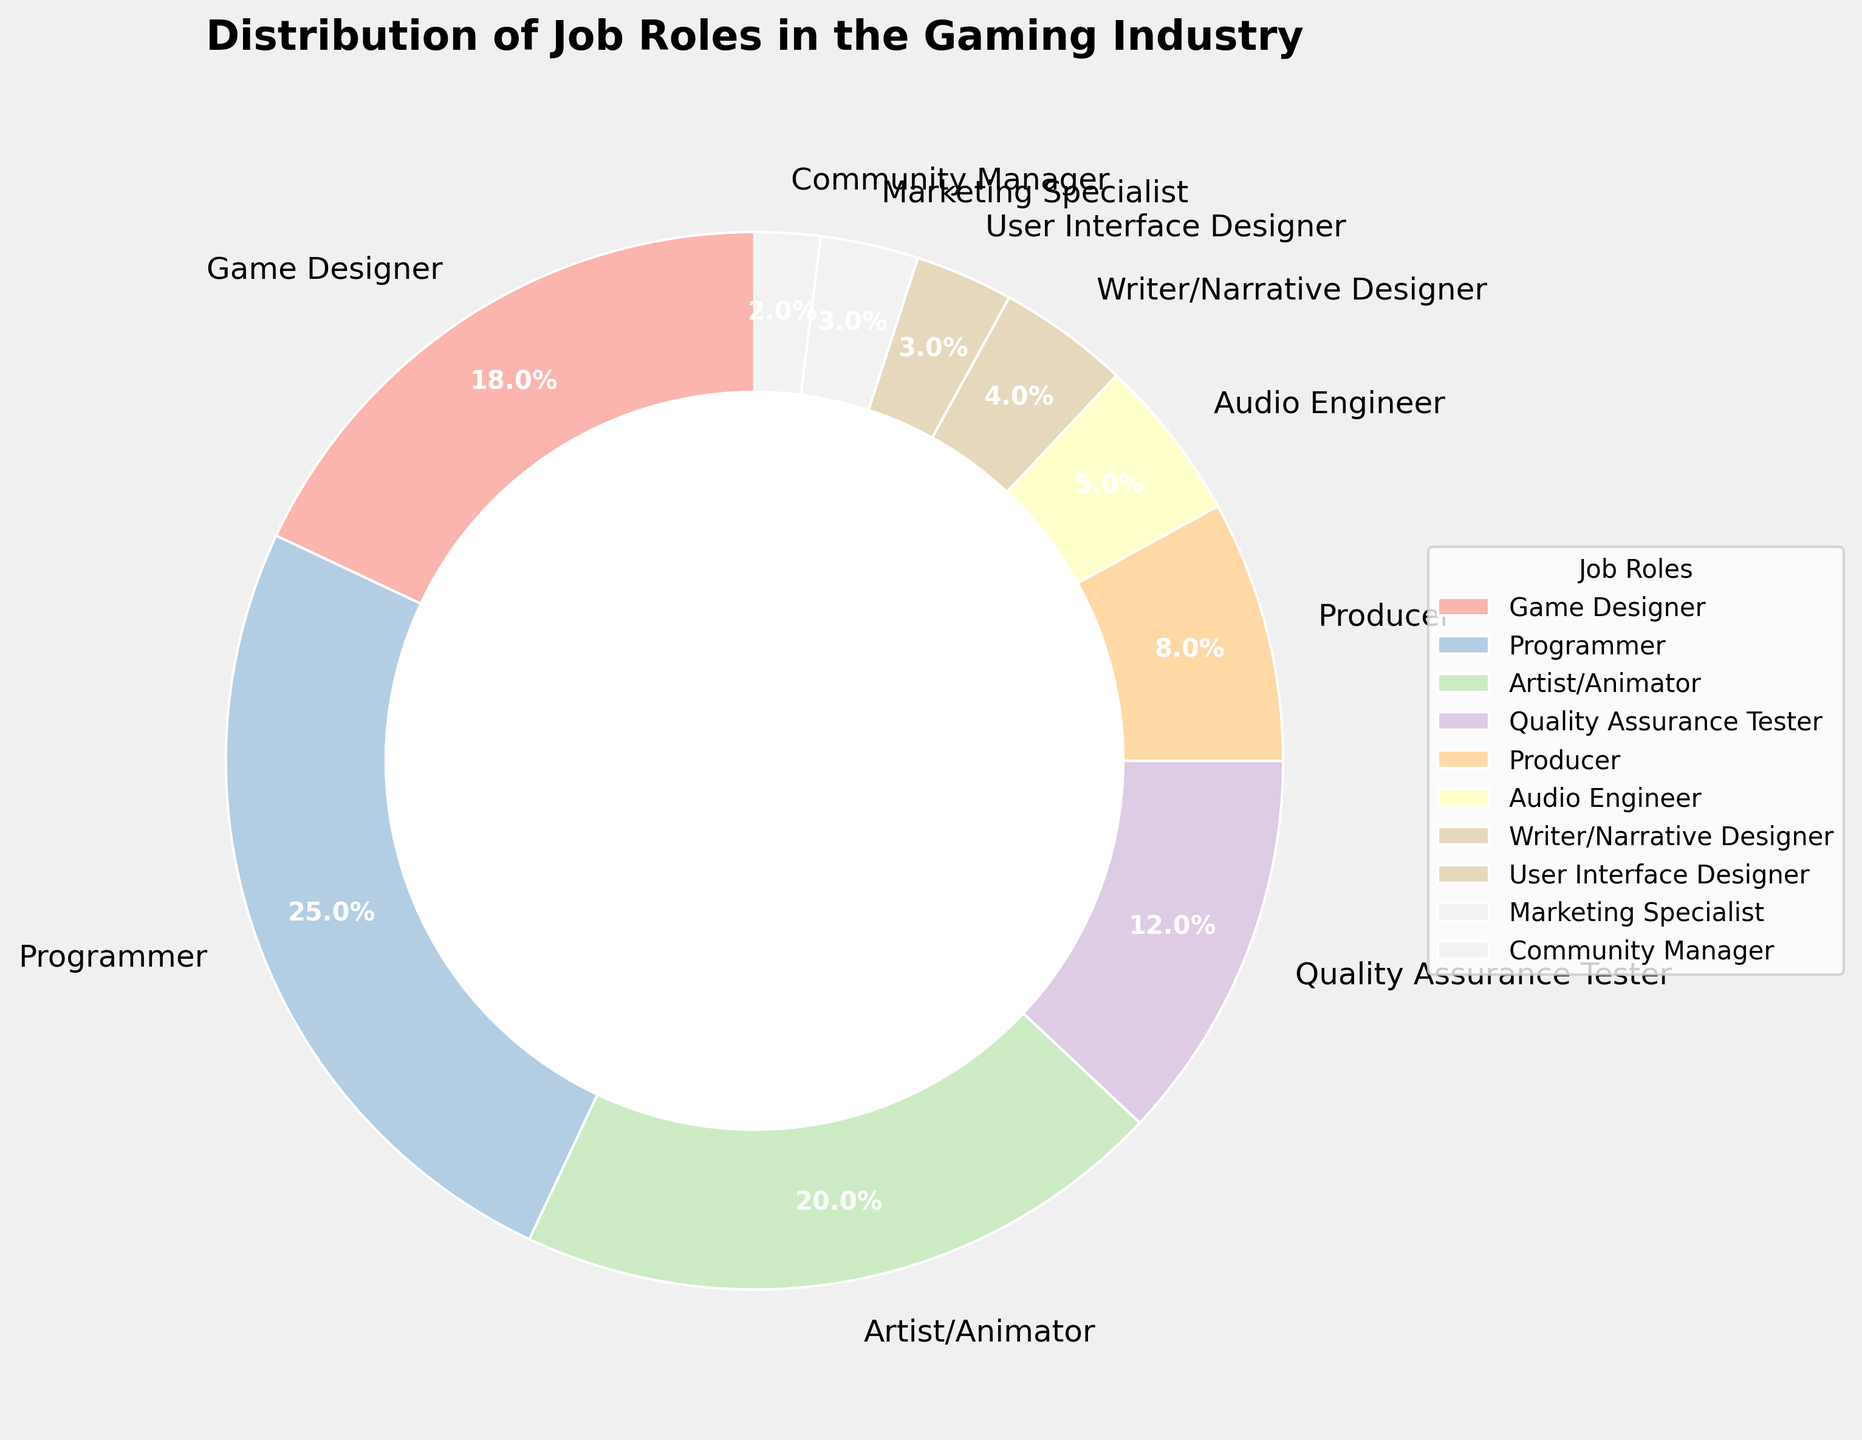Which job role has the largest percentage distribution in the gaming industry? The figure shows that the "Programmer" segment has the largest part of the pie chart with a 25% distribution.
Answer: Programmer What is the combined percentage of "Quality Assurance Tester" and "Producer" roles? According to the chart, the "Quality Assurance Tester" has a 12% share and the "Producer" has an 8% share. Adding them together: 12% + 8% = 20%.
Answer: 20% Which job roles have an equal representation percentage in the gaming industry? The pie chart shows that "User Interface Designer" and "Marketing Specialist" roles both have a 3% share.
Answer: User Interface Designer and Marketing Specialist What is the percentage difference between "Artist/Animator" and "Writer/Narrative Designer"? The chart indicates that "Artist/Animator" has a 20% share and "Writer/Narrative Designer" has a 4% share. The difference is 20% - 4% = 16%.
Answer: 16% Is the percentage share of "Audio Engineer" greater or less than the combined share of "Community Manager" and "User Interface Designer"? "Audio Engineer" has a 5% share. The combined share of "Community Manager" (2%) and "User Interface Designer" (3%) is 2% + 3% = 5%. Both shares are equal.
Answer: Equal How much more significant is the "Programmer" role compared to the "Game Designer" role in terms of percentage? "Programmer" has a 25% share, while "Game Designer" has an 18% share. The difference is 25% - 18% = 7%.
Answer: 7% Which job role is represented by the smallest segment in the pie chart? The smallest segment in the pie chart represents the "Community Manager" role, which has a 2% share.
Answer: Community Manager If the "Community Manager" roles were to double in percentage, what would the new total percentage be for the pie chart? The current share for "Community Manager" is 2%. If it doubled, it would become 4%. Since we initially had a complete 100%, increasing "Community Manager" by 2% will result in a new total of 102%.
Answer: 102% What is the sum of the percentages of all job roles that are under 5%? The roles under 5% are "Writer/Narrative Designer" (4%), "User Interface Designer" (3%), "Marketing Specialist" (3%), and "Community Manager" (2%). Summing them up: 4% + 3% + 3% + 2% = 12%.
Answer: 12% Which color segment in the pie chart represents the "Game Designer" role? The "Game Designer" role is represented by the section labeled "18%", which matches visually the part of the pie chart.
Answer: 18% 